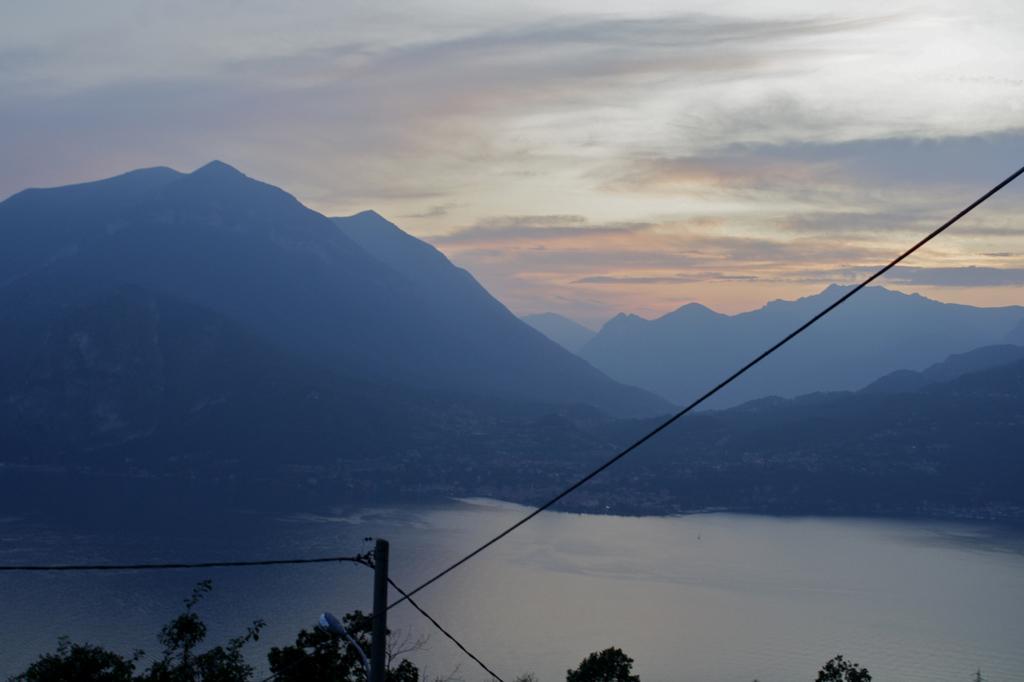Could you give a brief overview of what you see in this image? In this image, we can see some trees, we can see water, there are some mountains, at the top there is a sky. 